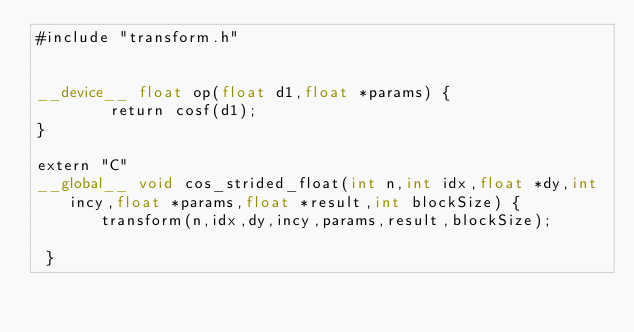<code> <loc_0><loc_0><loc_500><loc_500><_Cuda_>#include "transform.h"


__device__ float op(float d1,float *params) {
        return cosf(d1);
}

extern "C"
__global__ void cos_strided_float(int n,int idx,float *dy,int incy,float *params,float *result,int blockSize) {
       transform(n,idx,dy,incy,params,result,blockSize);

 }
</code> 